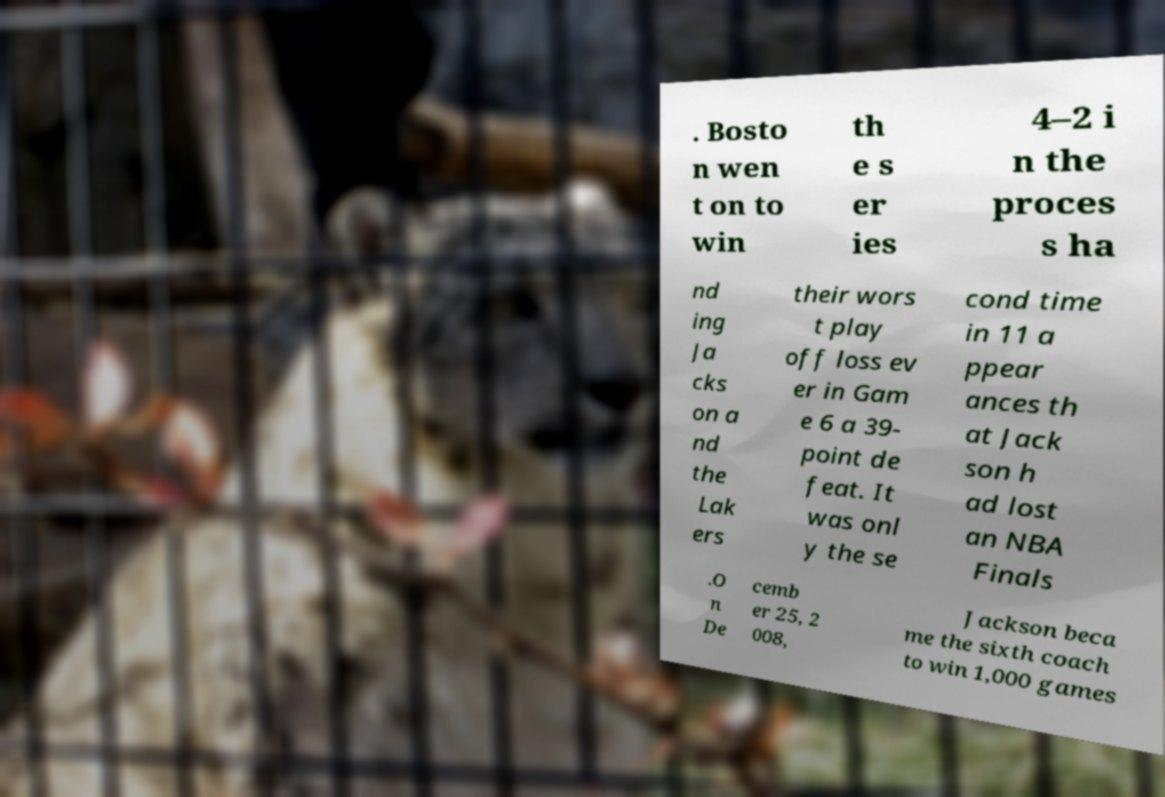For documentation purposes, I need the text within this image transcribed. Could you provide that? . Bosto n wen t on to win th e s er ies 4–2 i n the proces s ha nd ing Ja cks on a nd the Lak ers their wors t play off loss ev er in Gam e 6 a 39- point de feat. It was onl y the se cond time in 11 a ppear ances th at Jack son h ad lost an NBA Finals .O n De cemb er 25, 2 008, Jackson beca me the sixth coach to win 1,000 games 